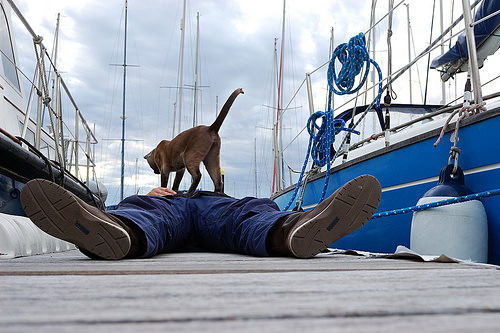<image>
Can you confirm if the animal is on the man? Yes. Looking at the image, I can see the animal is positioned on top of the man, with the man providing support. 